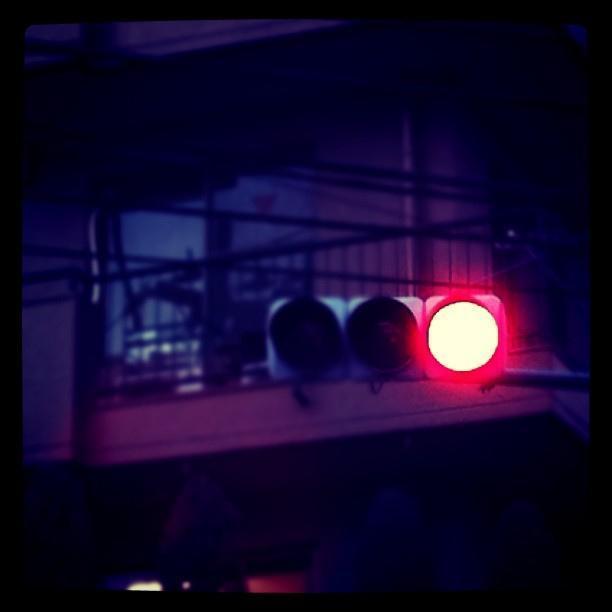How many light sockets are there?
Give a very brief answer. 3. How many lights are on?
Give a very brief answer. 1. How many traffic lights are in the photo?
Give a very brief answer. 1. 